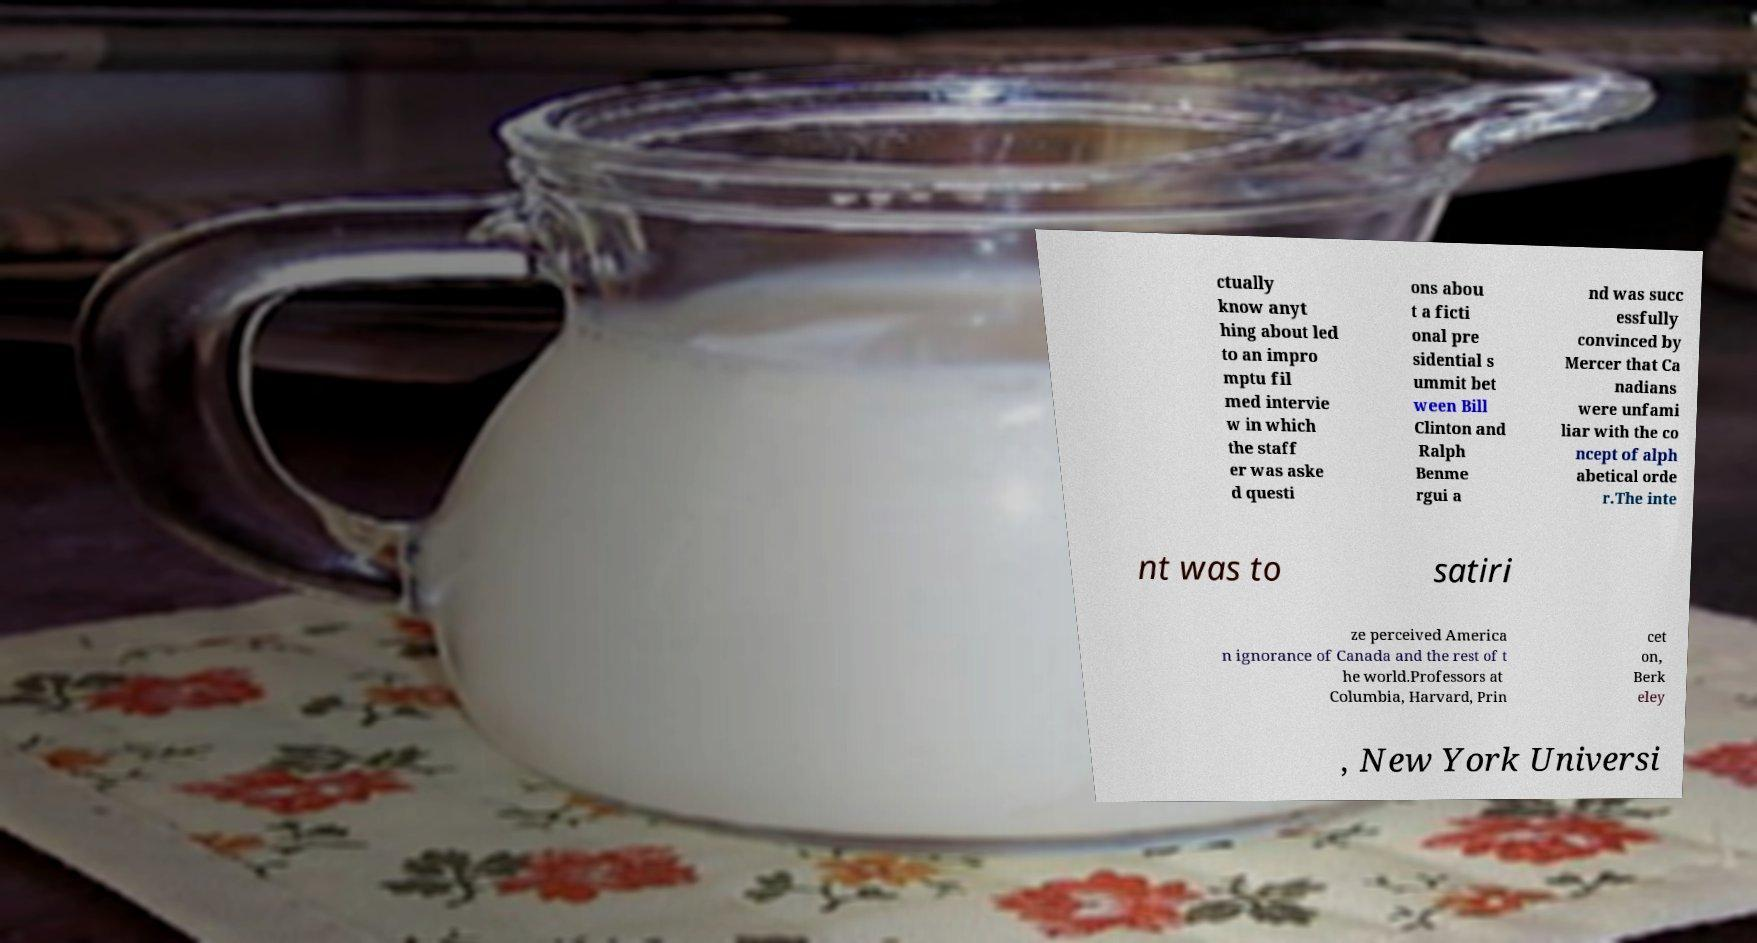Can you read and provide the text displayed in the image?This photo seems to have some interesting text. Can you extract and type it out for me? ctually know anyt hing about led to an impro mptu fil med intervie w in which the staff er was aske d questi ons abou t a ficti onal pre sidential s ummit bet ween Bill Clinton and Ralph Benme rgui a nd was succ essfully convinced by Mercer that Ca nadians were unfami liar with the co ncept of alph abetical orde r.The inte nt was to satiri ze perceived America n ignorance of Canada and the rest of t he world.Professors at Columbia, Harvard, Prin cet on, Berk eley , New York Universi 